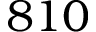<formula> <loc_0><loc_0><loc_500><loc_500>8 1 0</formula> 